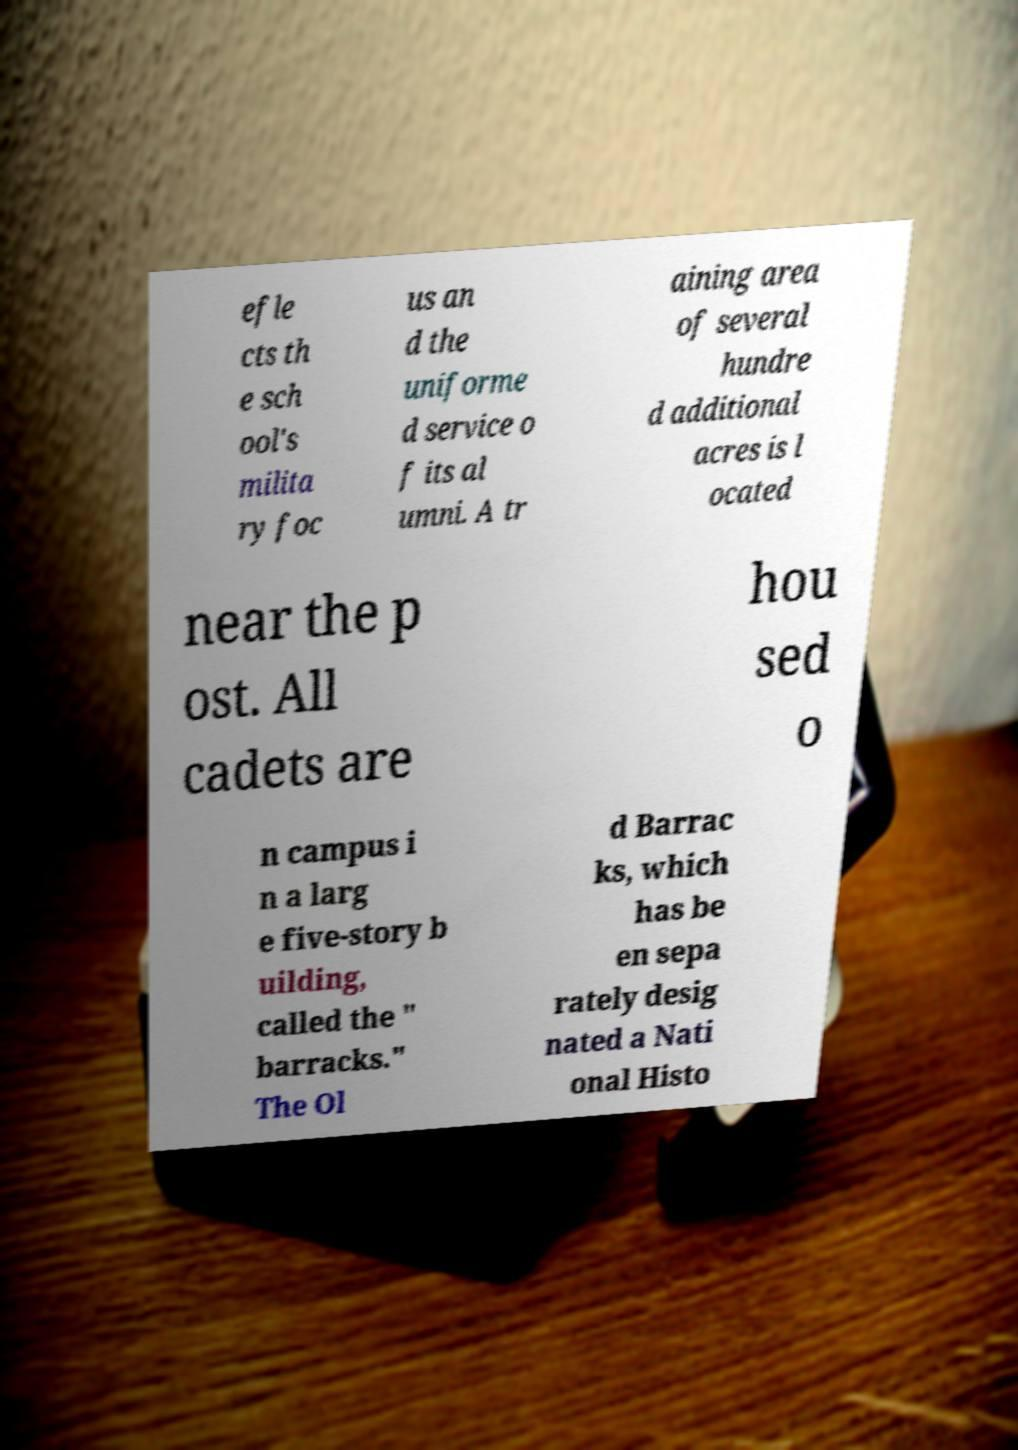Can you read and provide the text displayed in the image?This photo seems to have some interesting text. Can you extract and type it out for me? efle cts th e sch ool's milita ry foc us an d the uniforme d service o f its al umni. A tr aining area of several hundre d additional acres is l ocated near the p ost. All cadets are hou sed o n campus i n a larg e five-story b uilding, called the " barracks." The Ol d Barrac ks, which has be en sepa rately desig nated a Nati onal Histo 